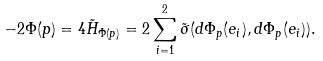Convert formula to latex. <formula><loc_0><loc_0><loc_500><loc_500>- 2 \Phi ( p ) = 4 \tilde { H } _ { \Phi ( p ) } = 2 \sum _ { i = 1 } ^ { 2 } \tilde { \sigma } ( d \Phi _ { p } ( e _ { i } ) , d \Phi _ { p } ( e _ { i } ) ) .</formula> 